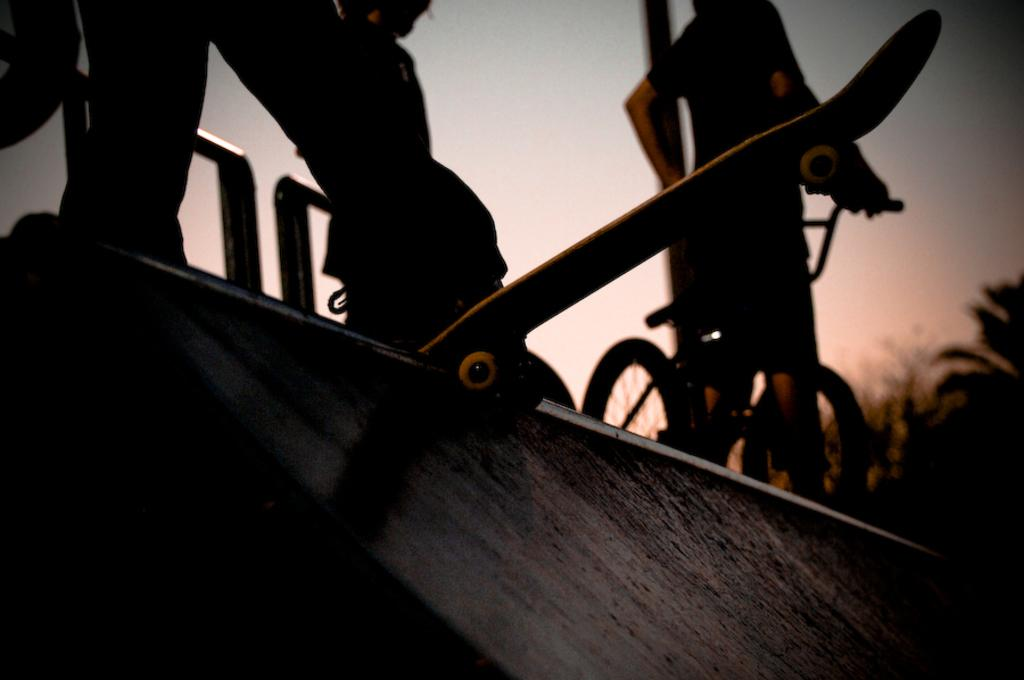What is the main subject of the image? The main subject of the image is a human standing on a skateboard. Can you describe the other person in the image? There is a person standing with a cycle on the right side of the image. What type of education is being taught in the image? There is no indication of education in the image; it features a person on a skateboard and another person with a cycle. Can you describe the hose used for watering plants in the image? There is no hose present in the image. 